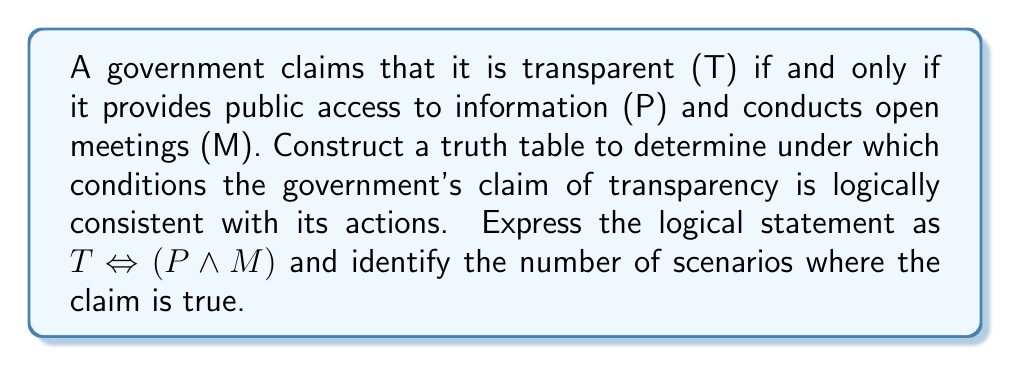Show me your answer to this math problem. Let's approach this step-by-step:

1) First, we need to construct a truth table for the statement $T \Leftrightarrow (P \wedge M)$.

2) We have three variables: T, P, and M. So our truth table will have $2^3 = 8$ rows.

3) Let's construct the table:

   | T | P | M | P ∧ M | T ⇔ (P ∧ M) |
   |---|---|---|-------|---------------|
   | 0 | 0 | 0 |   0   |       1       |
   | 0 | 0 | 1 |   0   |       1       |
   | 0 | 1 | 0 |   0   |       1       |
   | 0 | 1 | 1 |   1   |       0       |
   | 1 | 0 | 0 |   0   |       0       |
   | 1 | 0 | 1 |   0   |       0       |
   | 1 | 1 | 0 |   0   |       0       |
   | 1 | 1 | 1 |   1   |       1       |

4) To fill in the "P ∧ M" column, we use the AND operation: it's 1 only when both P and M are 1.

5) For the final column "T ⇔ (P ∧ M)", we use the biconditional (if and only if) operation:
   It's true (1) when both sides have the same truth value (both true or both false).

6) Now, we need to count the number of scenarios where the claim is true (i.e., where the last column is 1).

7) Counting the 1's in the last column, we see there are 4 scenarios where the claim is logically consistent.

Therefore, the government's claim of transparency is logically consistent with its actions in 4 out of 8 possible scenarios.
Answer: 4 